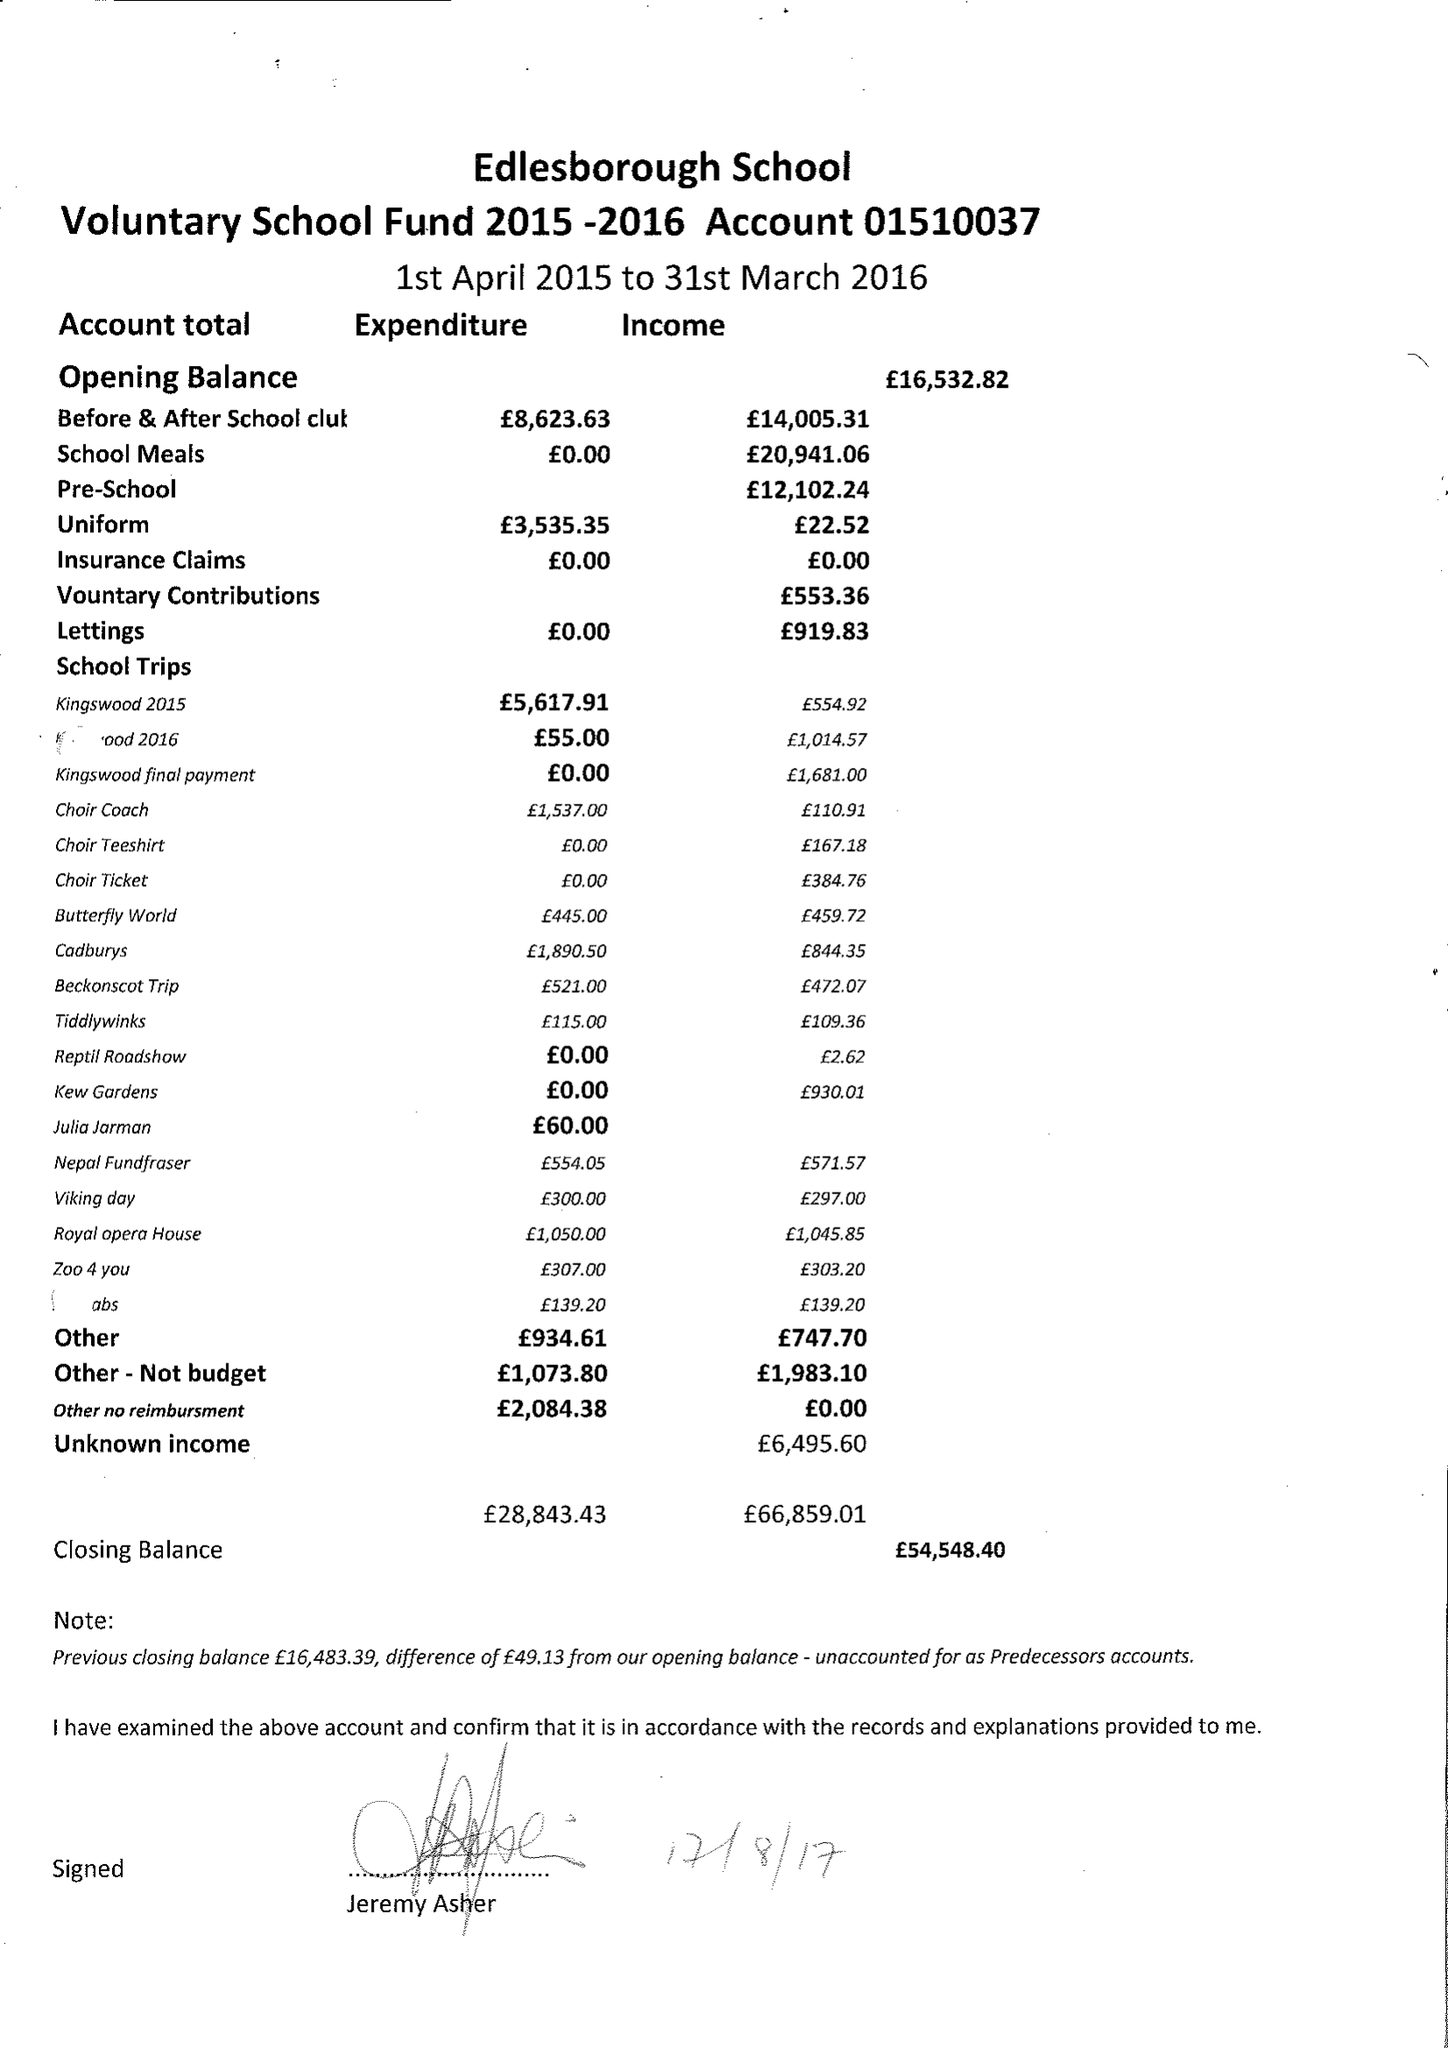What is the value for the report_date?
Answer the question using a single word or phrase. 2016-03-31 